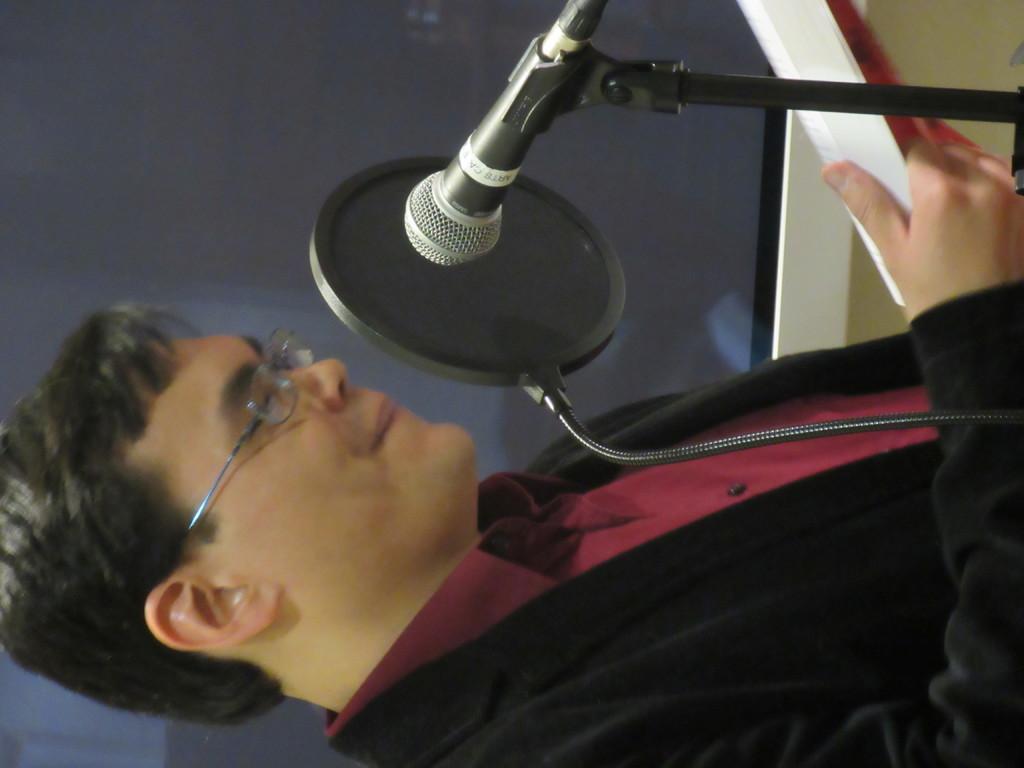Can you describe this image briefly? In this image we can see a person wearing a black blazer, maroon color shirt and spectacles is holding a book in his hands and smiling. Here we can see a mic is kept to the stand. In the background, we can see the wall. 